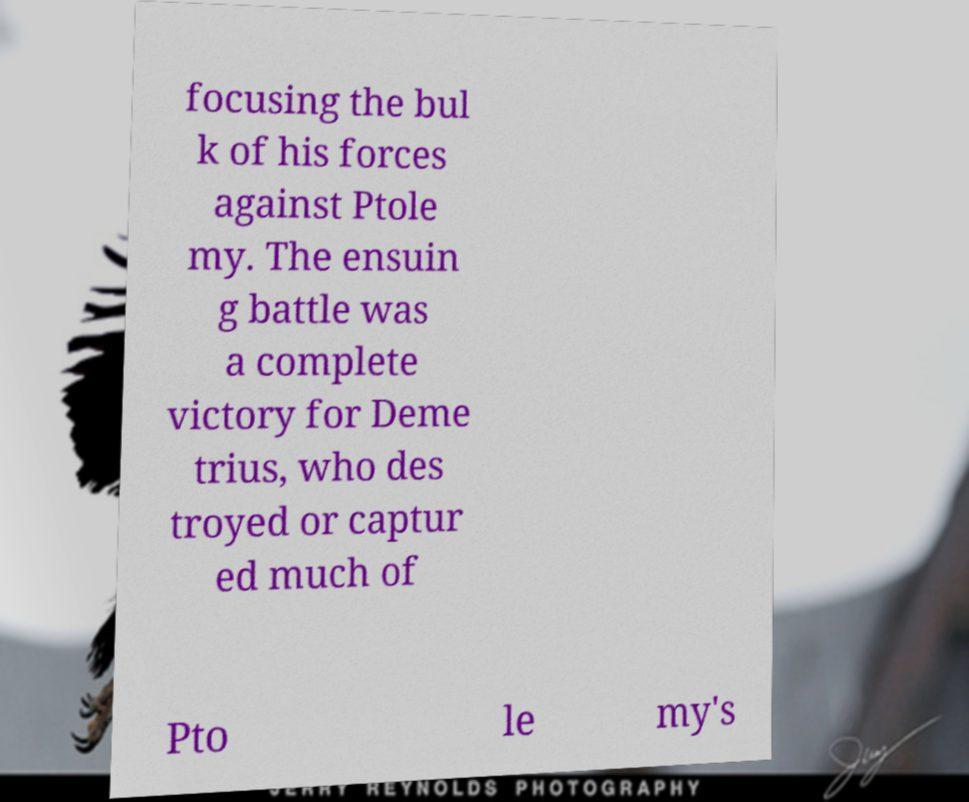There's text embedded in this image that I need extracted. Can you transcribe it verbatim? focusing the bul k of his forces against Ptole my. The ensuin g battle was a complete victory for Deme trius, who des troyed or captur ed much of Pto le my's 